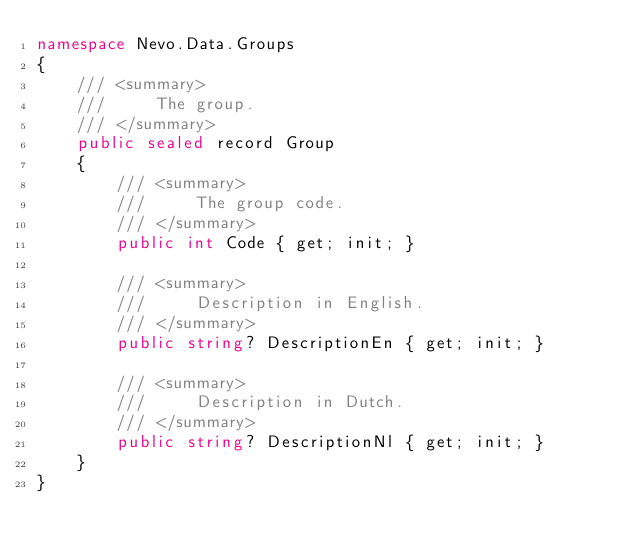Convert code to text. <code><loc_0><loc_0><loc_500><loc_500><_C#_>namespace Nevo.Data.Groups
{
    /// <summary>
    ///     The group.
    /// </summary>
    public sealed record Group
    {
        /// <summary>
        ///     The group code.
        /// </summary>
        public int Code { get; init; }

        /// <summary>
        ///     Description in English.
        /// </summary>
        public string? DescriptionEn { get; init; }

        /// <summary>
        ///     Description in Dutch.
        /// </summary>
        public string? DescriptionNl { get; init; }
    }
}</code> 